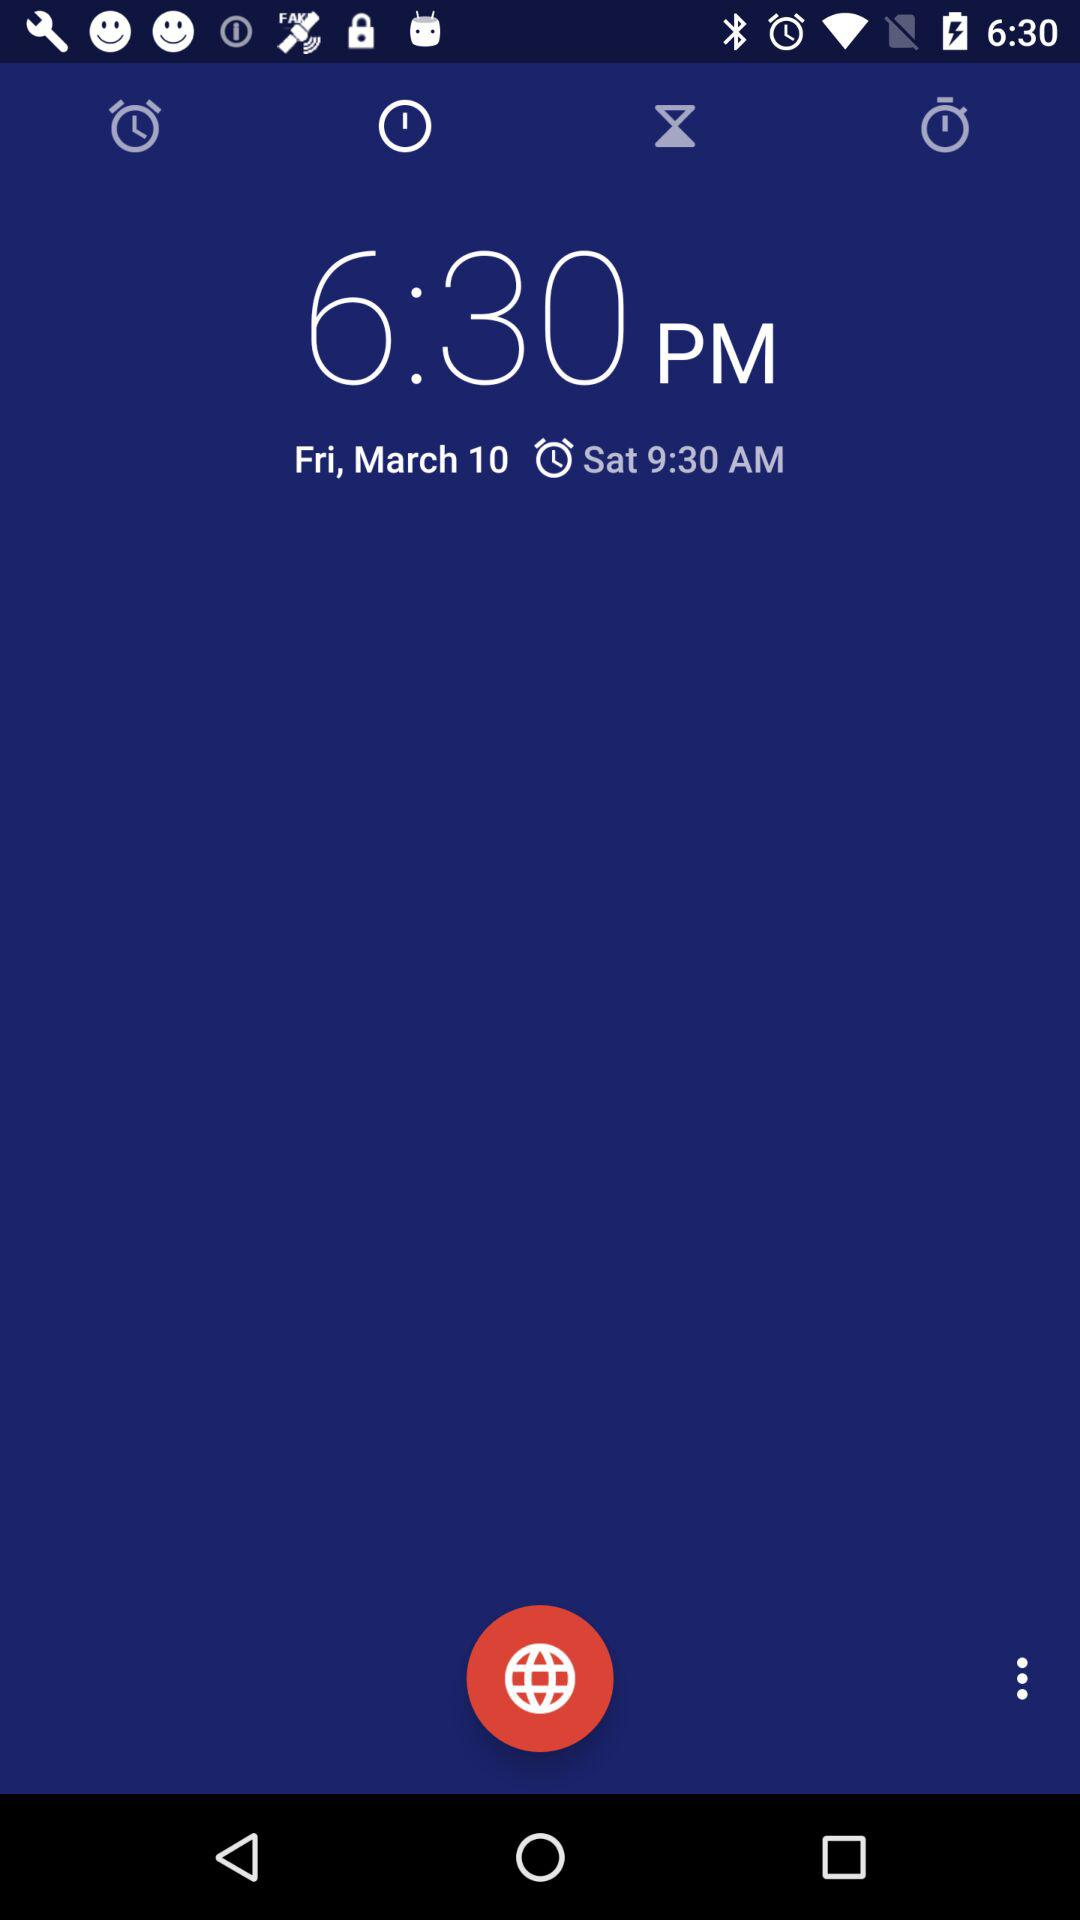How many days difference is there between the two dates?
Answer the question using a single word or phrase. 1 